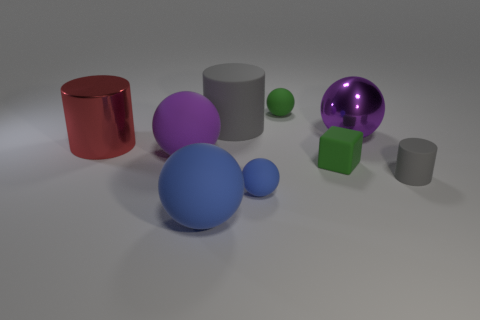Subtract all big gray cylinders. How many cylinders are left? 2 Subtract all red cylinders. How many cylinders are left? 2 Subtract all cylinders. How many objects are left? 6 Subtract 1 cylinders. How many cylinders are left? 2 Subtract all red cylinders. Subtract all yellow balls. How many cylinders are left? 2 Subtract all red balls. How many red cylinders are left? 1 Subtract all small rubber cylinders. Subtract all big red shiny cylinders. How many objects are left? 7 Add 5 large things. How many large things are left? 10 Add 2 small blue rubber objects. How many small blue rubber objects exist? 3 Subtract 0 cyan balls. How many objects are left? 9 